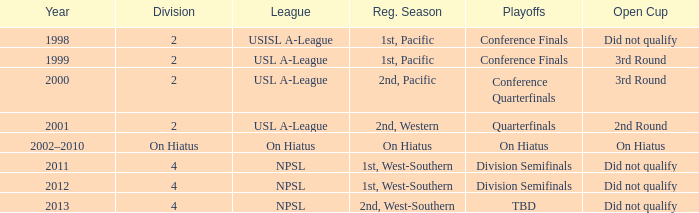When were the conference finals in the usl a-league? 1999.0. 